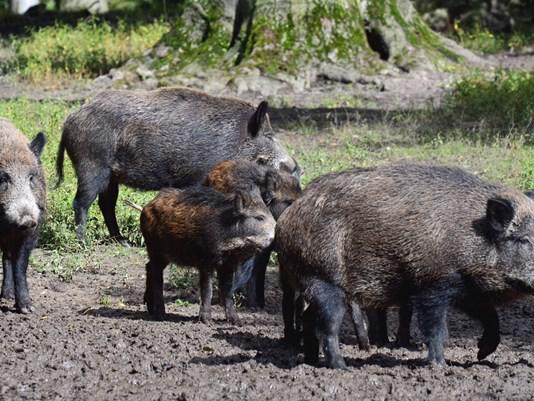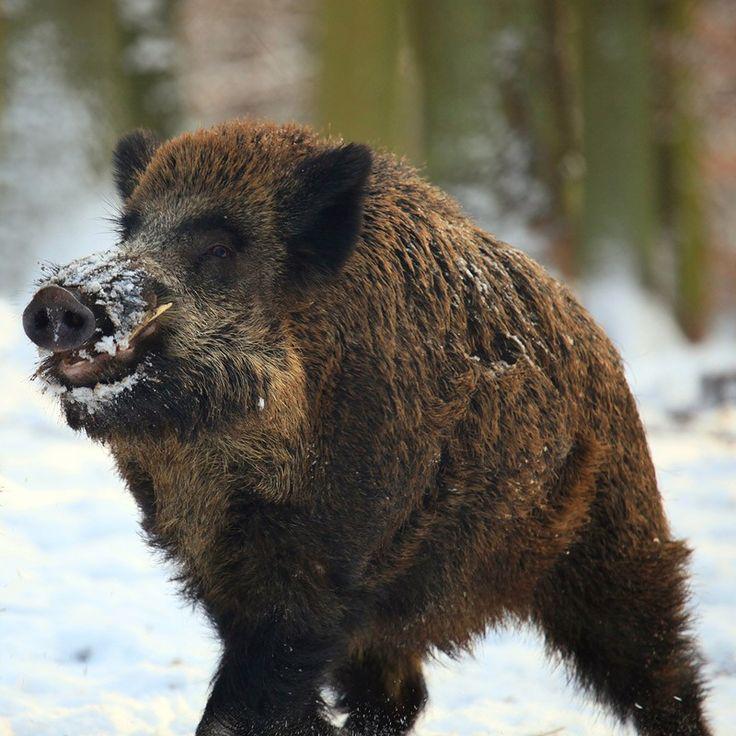The first image is the image on the left, the second image is the image on the right. Analyze the images presented: Is the assertion "At least one of the images shows exactly one boar." valid? Answer yes or no. Yes. The first image is the image on the left, the second image is the image on the right. Analyze the images presented: Is the assertion "there is exactly one boar in the image on the right" valid? Answer yes or no. Yes. 